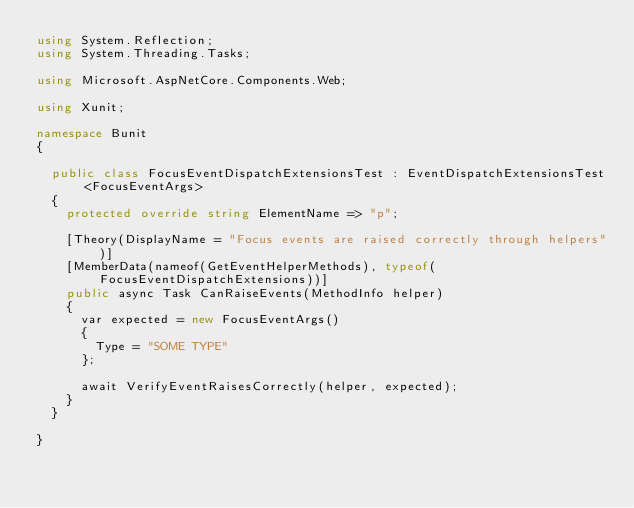<code> <loc_0><loc_0><loc_500><loc_500><_C#_>using System.Reflection;
using System.Threading.Tasks;

using Microsoft.AspNetCore.Components.Web;

using Xunit;

namespace Bunit
{

	public class FocusEventDispatchExtensionsTest : EventDispatchExtensionsTest<FocusEventArgs>
	{
		protected override string ElementName => "p";

		[Theory(DisplayName = "Focus events are raised correctly through helpers")]
		[MemberData(nameof(GetEventHelperMethods), typeof(FocusEventDispatchExtensions))]
		public async Task CanRaiseEvents(MethodInfo helper)
		{
			var expected = new FocusEventArgs()
			{
				Type = "SOME TYPE"
			};

			await VerifyEventRaisesCorrectly(helper, expected);
		}
	}

}

</code> 